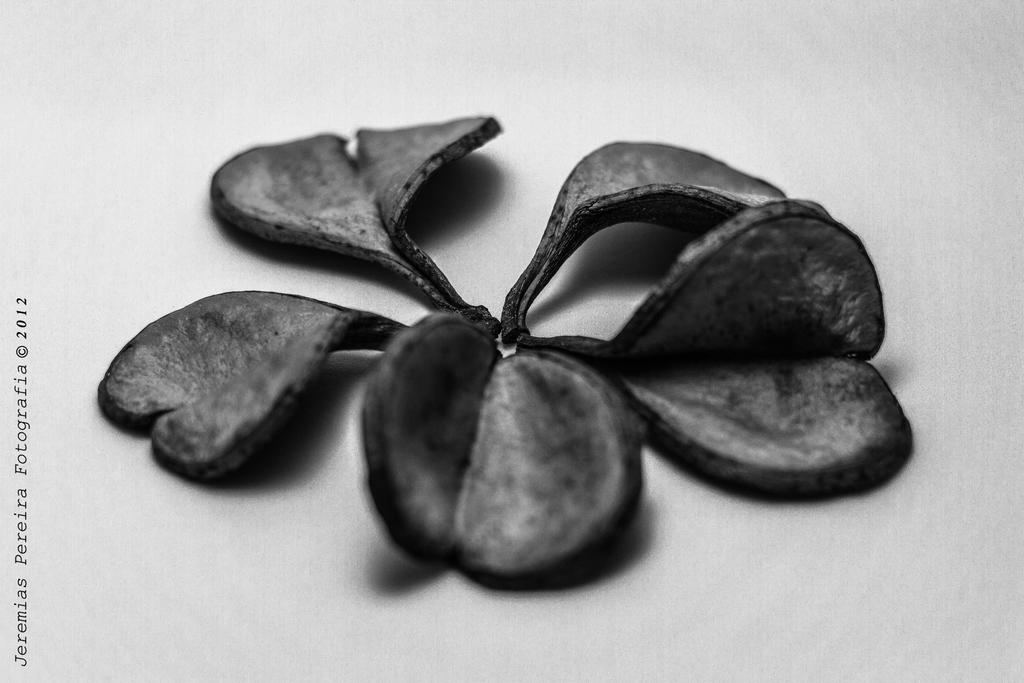What color is the flower in the image? The flower in the image is black. What color is the surface on which the flower is placed? The surface is white. What can be found on the surface besides the flower? There is writing on the surface. What is the taste of the flower in the image? Flowers do not have a taste, so this question cannot be answered based on the image. 